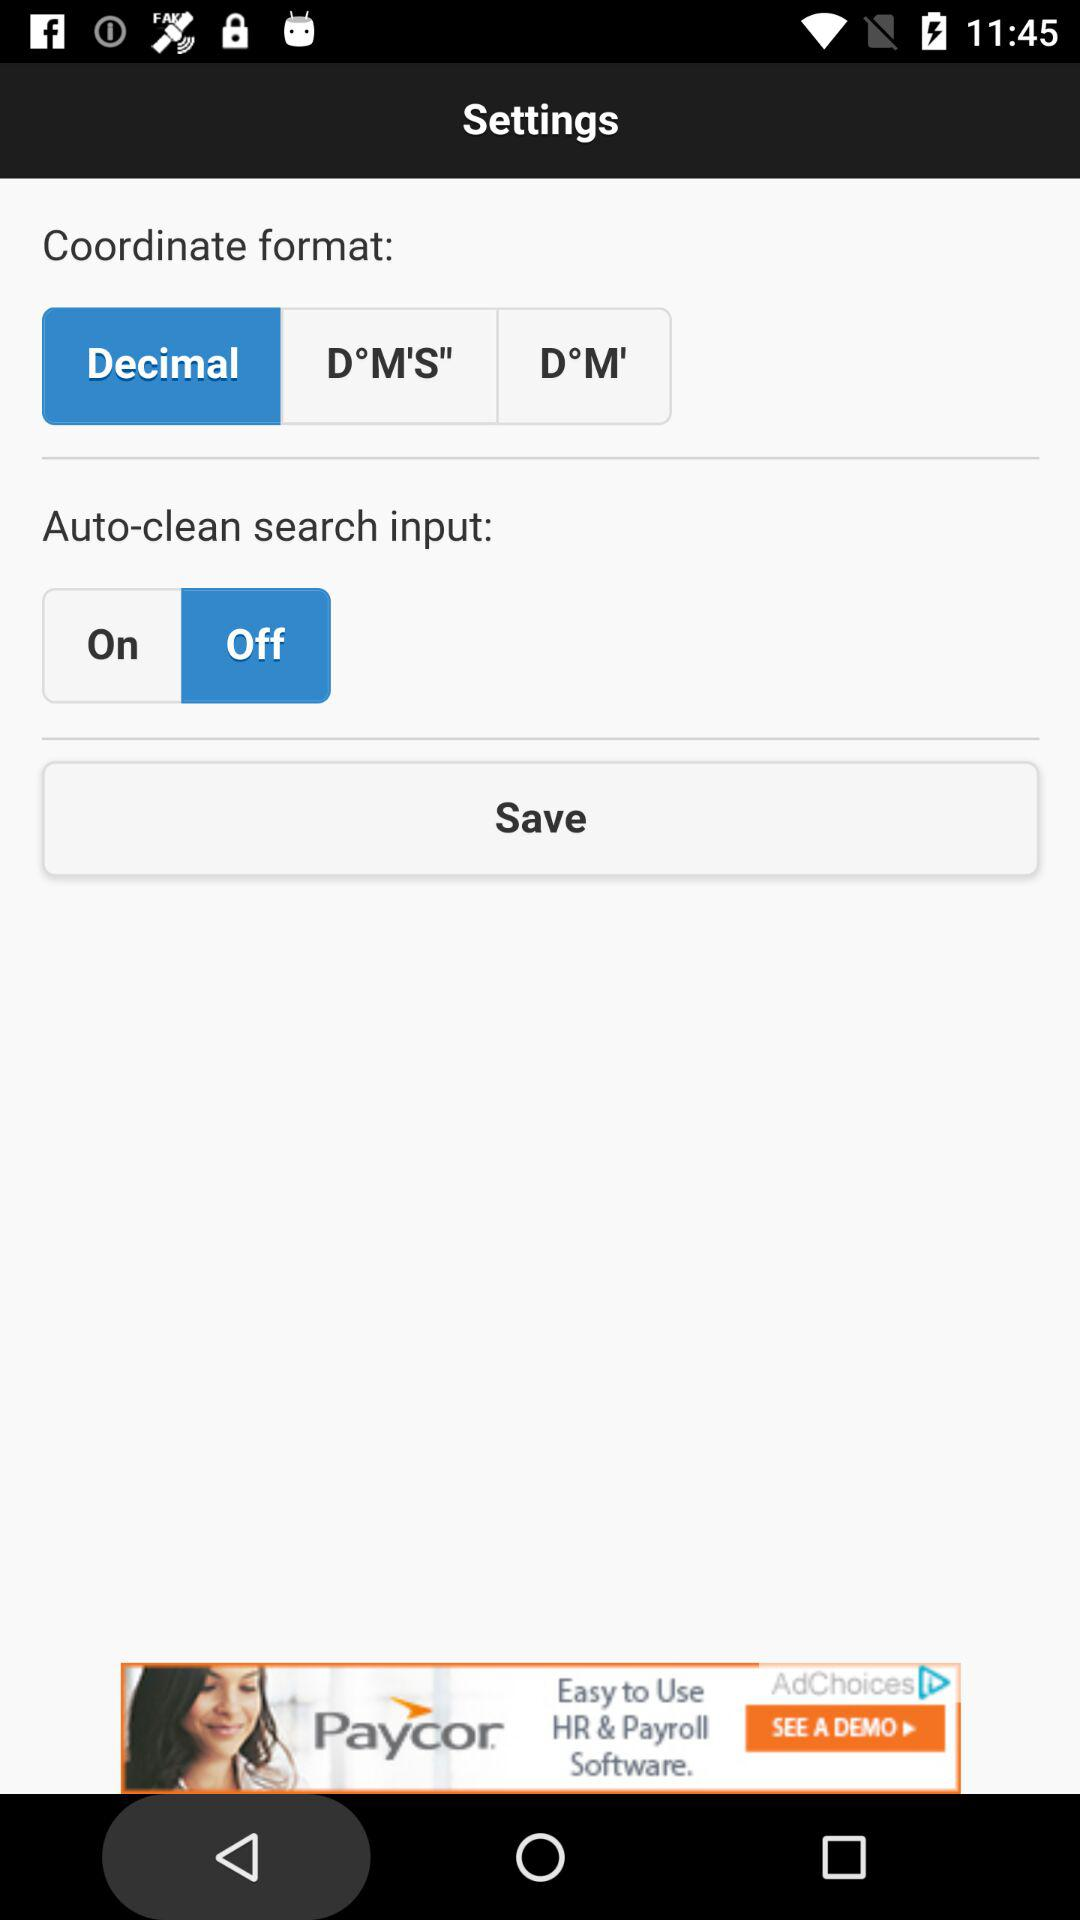Which coordinate format is selected? The selected coordinate format is "Decimal". 